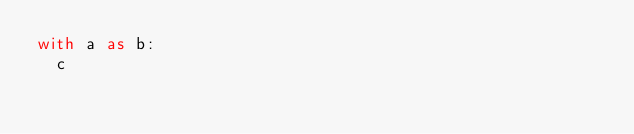<code> <loc_0><loc_0><loc_500><loc_500><_Python_>with a as b:
  c
</code> 